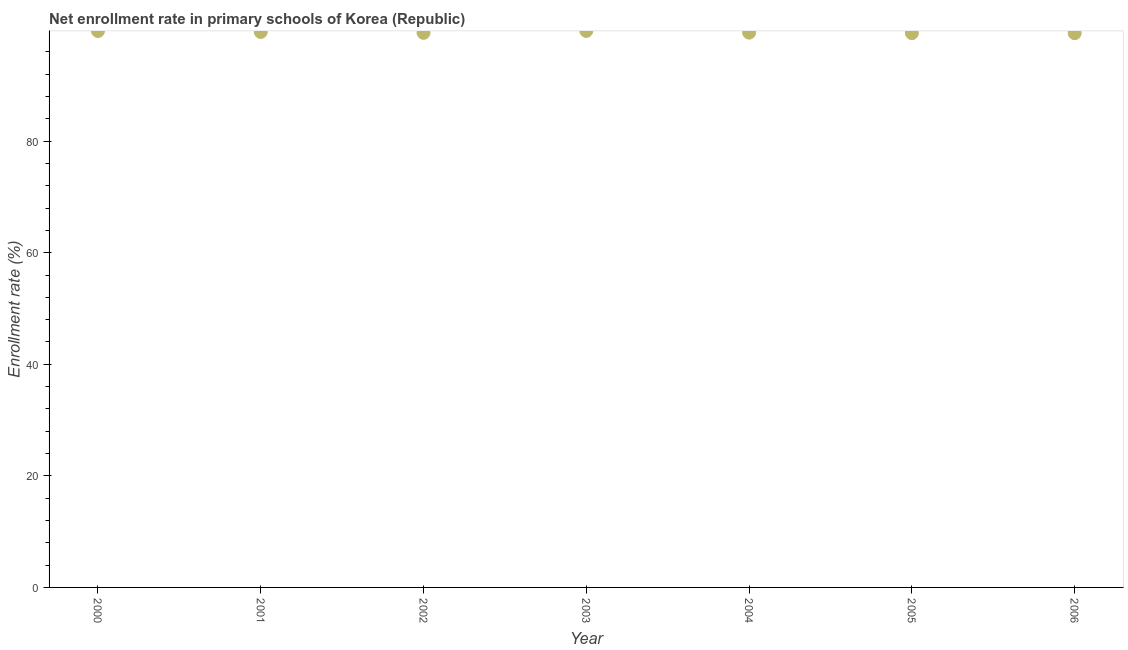What is the net enrollment rate in primary schools in 2005?
Provide a short and direct response. 99.37. Across all years, what is the maximum net enrollment rate in primary schools?
Your answer should be very brief. 99.76. Across all years, what is the minimum net enrollment rate in primary schools?
Your answer should be compact. 99.36. In which year was the net enrollment rate in primary schools maximum?
Provide a short and direct response. 2003. What is the sum of the net enrollment rate in primary schools?
Your answer should be compact. 696.71. What is the difference between the net enrollment rate in primary schools in 2000 and 2006?
Offer a very short reply. 0.39. What is the average net enrollment rate in primary schools per year?
Keep it short and to the point. 99.53. What is the median net enrollment rate in primary schools?
Offer a very short reply. 99.46. In how many years, is the net enrollment rate in primary schools greater than 40 %?
Provide a short and direct response. 7. What is the ratio of the net enrollment rate in primary schools in 2000 to that in 2005?
Give a very brief answer. 1. Is the net enrollment rate in primary schools in 2001 less than that in 2005?
Your answer should be compact. No. What is the difference between the highest and the second highest net enrollment rate in primary schools?
Give a very brief answer. 0.01. Is the sum of the net enrollment rate in primary schools in 2000 and 2003 greater than the maximum net enrollment rate in primary schools across all years?
Your answer should be compact. Yes. What is the difference between the highest and the lowest net enrollment rate in primary schools?
Provide a succinct answer. 0.4. Does the net enrollment rate in primary schools monotonically increase over the years?
Offer a very short reply. No. How many years are there in the graph?
Offer a terse response. 7. What is the difference between two consecutive major ticks on the Y-axis?
Ensure brevity in your answer.  20. Are the values on the major ticks of Y-axis written in scientific E-notation?
Make the answer very short. No. Does the graph contain any zero values?
Offer a terse response. No. Does the graph contain grids?
Offer a very short reply. No. What is the title of the graph?
Provide a short and direct response. Net enrollment rate in primary schools of Korea (Republic). What is the label or title of the X-axis?
Make the answer very short. Year. What is the label or title of the Y-axis?
Make the answer very short. Enrollment rate (%). What is the Enrollment rate (%) in 2000?
Offer a terse response. 99.75. What is the Enrollment rate (%) in 2001?
Provide a succinct answer. 99.58. What is the Enrollment rate (%) in 2002?
Offer a terse response. 99.42. What is the Enrollment rate (%) in 2003?
Ensure brevity in your answer.  99.76. What is the Enrollment rate (%) in 2004?
Your answer should be compact. 99.46. What is the Enrollment rate (%) in 2005?
Keep it short and to the point. 99.37. What is the Enrollment rate (%) in 2006?
Give a very brief answer. 99.36. What is the difference between the Enrollment rate (%) in 2000 and 2001?
Offer a very short reply. 0.17. What is the difference between the Enrollment rate (%) in 2000 and 2002?
Give a very brief answer. 0.33. What is the difference between the Enrollment rate (%) in 2000 and 2003?
Offer a very short reply. -0.01. What is the difference between the Enrollment rate (%) in 2000 and 2004?
Your answer should be very brief. 0.29. What is the difference between the Enrollment rate (%) in 2000 and 2005?
Provide a short and direct response. 0.38. What is the difference between the Enrollment rate (%) in 2000 and 2006?
Offer a very short reply. 0.39. What is the difference between the Enrollment rate (%) in 2001 and 2002?
Your answer should be compact. 0.16. What is the difference between the Enrollment rate (%) in 2001 and 2003?
Keep it short and to the point. -0.18. What is the difference between the Enrollment rate (%) in 2001 and 2004?
Your answer should be very brief. 0.12. What is the difference between the Enrollment rate (%) in 2001 and 2005?
Give a very brief answer. 0.22. What is the difference between the Enrollment rate (%) in 2001 and 2006?
Offer a terse response. 0.22. What is the difference between the Enrollment rate (%) in 2002 and 2003?
Offer a terse response. -0.34. What is the difference between the Enrollment rate (%) in 2002 and 2004?
Provide a succinct answer. -0.04. What is the difference between the Enrollment rate (%) in 2002 and 2005?
Make the answer very short. 0.06. What is the difference between the Enrollment rate (%) in 2002 and 2006?
Make the answer very short. 0.06. What is the difference between the Enrollment rate (%) in 2003 and 2004?
Make the answer very short. 0.3. What is the difference between the Enrollment rate (%) in 2003 and 2005?
Provide a short and direct response. 0.4. What is the difference between the Enrollment rate (%) in 2003 and 2006?
Keep it short and to the point. 0.4. What is the difference between the Enrollment rate (%) in 2004 and 2005?
Offer a terse response. 0.09. What is the difference between the Enrollment rate (%) in 2004 and 2006?
Make the answer very short. 0.1. What is the difference between the Enrollment rate (%) in 2005 and 2006?
Offer a terse response. 0.01. What is the ratio of the Enrollment rate (%) in 2000 to that in 2001?
Provide a succinct answer. 1. What is the ratio of the Enrollment rate (%) in 2000 to that in 2004?
Make the answer very short. 1. What is the ratio of the Enrollment rate (%) in 2001 to that in 2002?
Give a very brief answer. 1. What is the ratio of the Enrollment rate (%) in 2001 to that in 2004?
Provide a succinct answer. 1. What is the ratio of the Enrollment rate (%) in 2001 to that in 2005?
Offer a very short reply. 1. What is the ratio of the Enrollment rate (%) in 2002 to that in 2003?
Your response must be concise. 1. What is the ratio of the Enrollment rate (%) in 2002 to that in 2005?
Give a very brief answer. 1. What is the ratio of the Enrollment rate (%) in 2005 to that in 2006?
Provide a succinct answer. 1. 